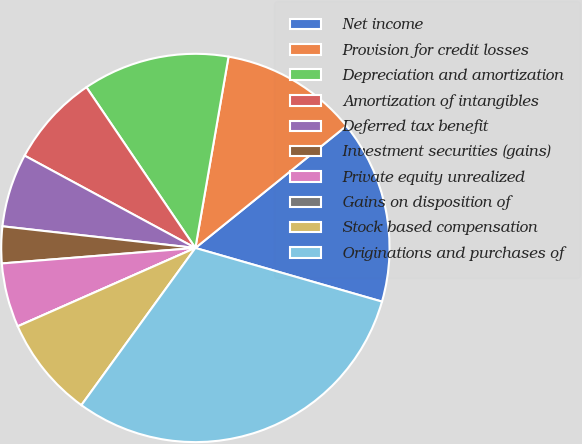Convert chart. <chart><loc_0><loc_0><loc_500><loc_500><pie_chart><fcel>Net income<fcel>Provision for credit losses<fcel>Depreciation and amortization<fcel>Amortization of intangibles<fcel>Deferred tax benefit<fcel>Investment securities (gains)<fcel>Private equity unrealized<fcel>Gains on disposition of<fcel>Stock based compensation<fcel>Originations and purchases of<nl><fcel>15.27%<fcel>11.45%<fcel>12.21%<fcel>7.63%<fcel>6.11%<fcel>3.05%<fcel>5.34%<fcel>0.0%<fcel>8.4%<fcel>30.53%<nl></chart> 